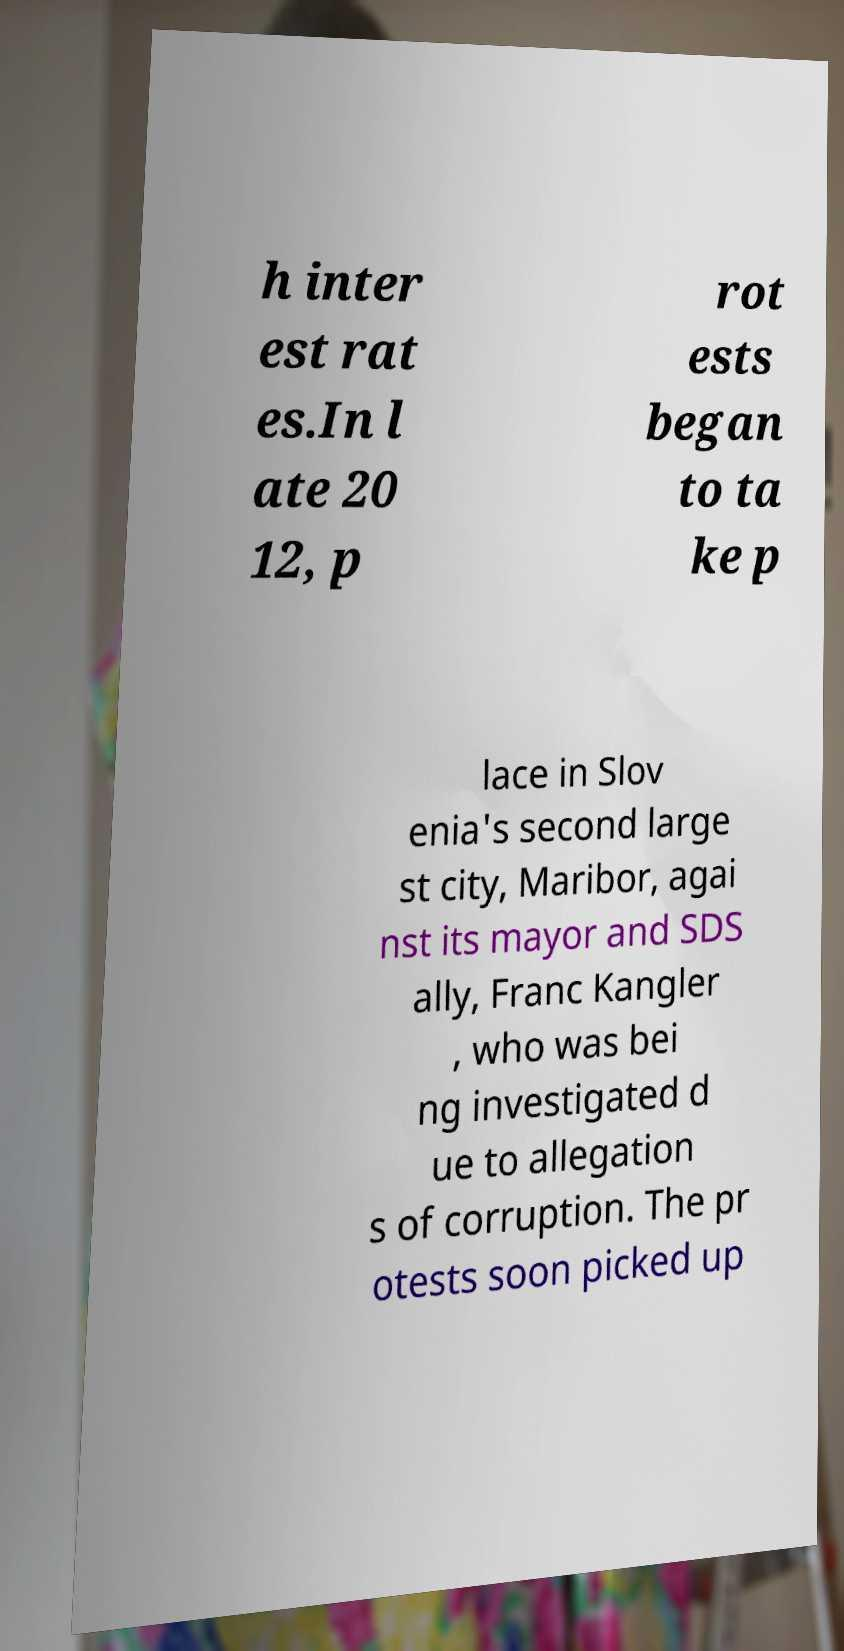What messages or text are displayed in this image? I need them in a readable, typed format. h inter est rat es.In l ate 20 12, p rot ests began to ta ke p lace in Slov enia's second large st city, Maribor, agai nst its mayor and SDS ally, Franc Kangler , who was bei ng investigated d ue to allegation s of corruption. The pr otests soon picked up 